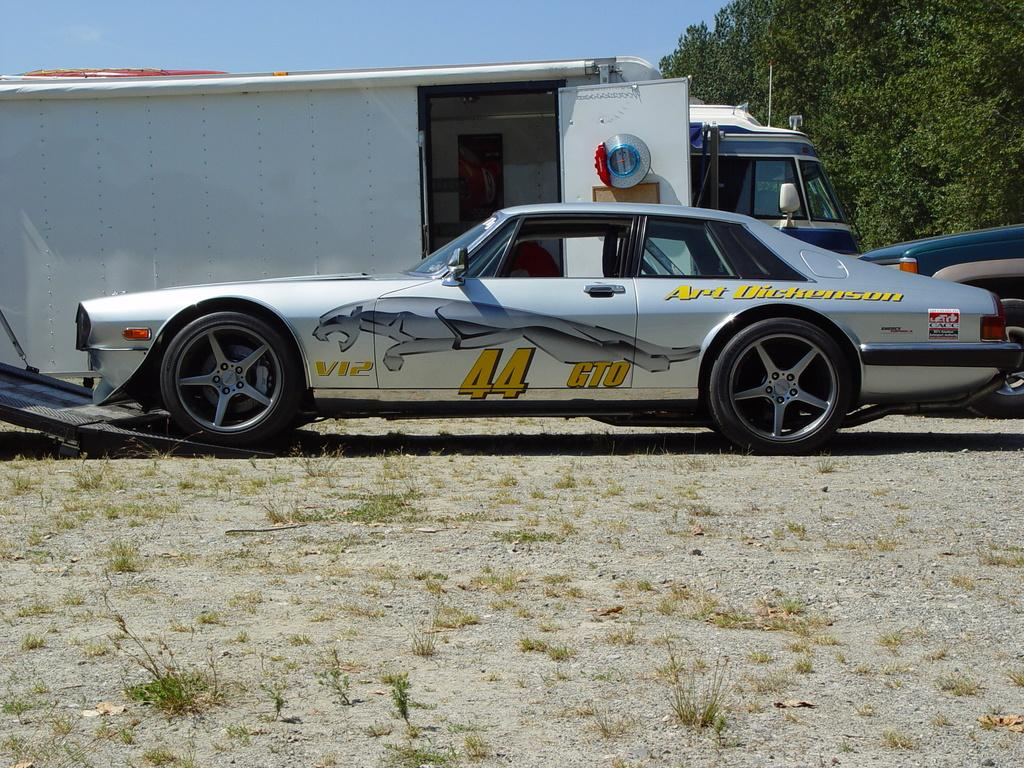What types of objects are present in the image? There are vehicles in the image. What is the ground surface like in the image? There is grass on the ground in the image. What can be seen in the background of the image? There are trees and the sky visible in the background of the image. Are there any fairies flying around the vehicles in the image? There is no mention of fairies in the image, and they are not visible. 